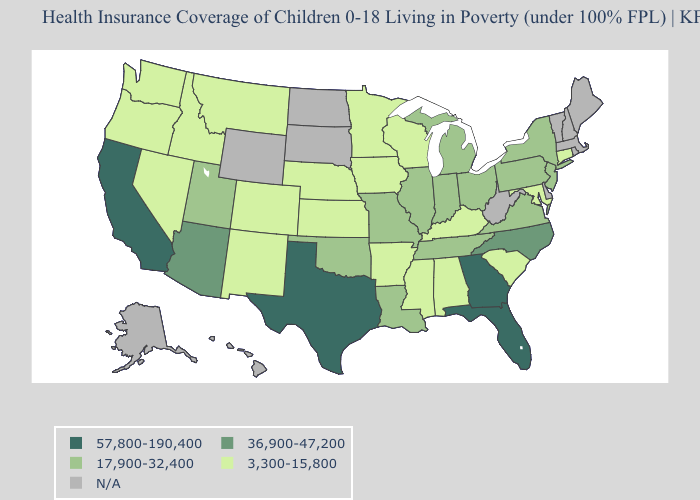What is the highest value in the South ?
Short answer required. 57,800-190,400. What is the lowest value in the West?
Keep it brief. 3,300-15,800. Name the states that have a value in the range 17,900-32,400?
Answer briefly. Illinois, Indiana, Louisiana, Michigan, Missouri, New Jersey, New York, Ohio, Oklahoma, Pennsylvania, Tennessee, Utah, Virginia. Among the states that border South Carolina , does Georgia have the highest value?
Give a very brief answer. Yes. What is the value of Nevada?
Be succinct. 3,300-15,800. Among the states that border Alabama , does Mississippi have the lowest value?
Answer briefly. Yes. What is the value of Arkansas?
Keep it brief. 3,300-15,800. What is the highest value in the USA?
Be succinct. 57,800-190,400. Does Minnesota have the lowest value in the USA?
Concise answer only. Yes. Name the states that have a value in the range 3,300-15,800?
Give a very brief answer. Alabama, Arkansas, Colorado, Connecticut, Idaho, Iowa, Kansas, Kentucky, Maryland, Minnesota, Mississippi, Montana, Nebraska, Nevada, New Mexico, Oregon, South Carolina, Washington, Wisconsin. How many symbols are there in the legend?
Keep it brief. 5. Among the states that border Indiana , which have the highest value?
Short answer required. Illinois, Michigan, Ohio. Name the states that have a value in the range 3,300-15,800?
Give a very brief answer. Alabama, Arkansas, Colorado, Connecticut, Idaho, Iowa, Kansas, Kentucky, Maryland, Minnesota, Mississippi, Montana, Nebraska, Nevada, New Mexico, Oregon, South Carolina, Washington, Wisconsin. 